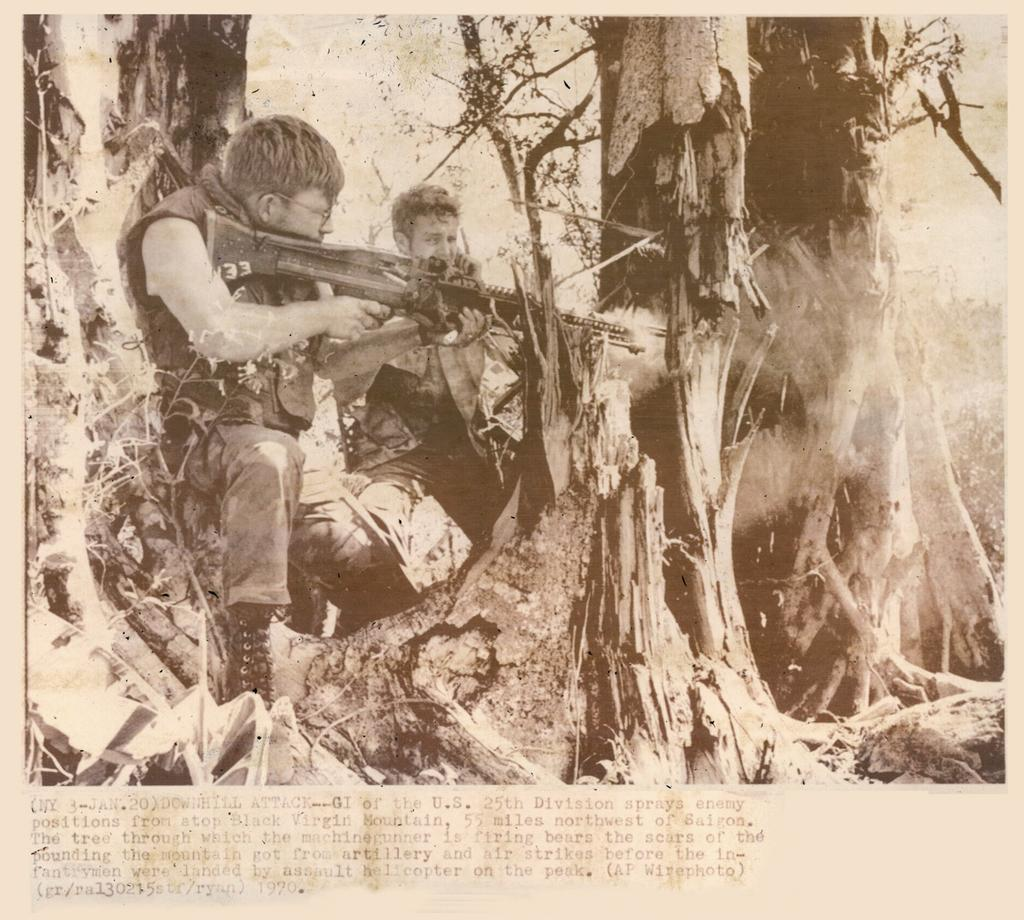How many people are in the image? There are two people in the image. What are the two people doing in the image? The two people are standing behind a tree. Can you describe the actions of one of the people? One of the people is holding a gun and trying to shoot something. Can the person with the gun help the can run faster in the image? There is no can or running depicted in the image, so it is not possible to determine if the person with the gun can help the can run faster. 